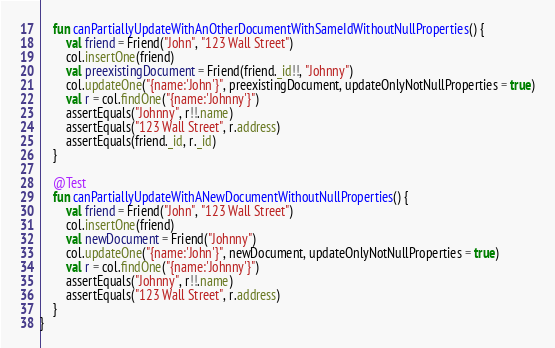Convert code to text. <code><loc_0><loc_0><loc_500><loc_500><_Kotlin_>    fun canPartiallyUpdateWithAnOtherDocumentWithSameIdWithoutNullProperties() {
        val friend = Friend("John", "123 Wall Street")
        col.insertOne(friend)
        val preexistingDocument = Friend(friend._id!!, "Johnny")
        col.updateOne("{name:'John'}", preexistingDocument, updateOnlyNotNullProperties = true)
        val r = col.findOne("{name:'Johnny'}")
        assertEquals("Johnny", r!!.name)
        assertEquals("123 Wall Street", r.address)
        assertEquals(friend._id, r._id)
    }

    @Test
    fun canPartiallyUpdateWithANewDocumentWithoutNullProperties() {
        val friend = Friend("John", "123 Wall Street")
        col.insertOne(friend)
        val newDocument = Friend("Johnny")
        col.updateOne("{name:'John'}", newDocument, updateOnlyNotNullProperties = true)
        val r = col.findOne("{name:'Johnny'}")
        assertEquals("Johnny", r!!.name)
        assertEquals("123 Wall Street", r.address)
    }
}</code> 